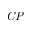Convert formula to latex. <formula><loc_0><loc_0><loc_500><loc_500>C P</formula> 